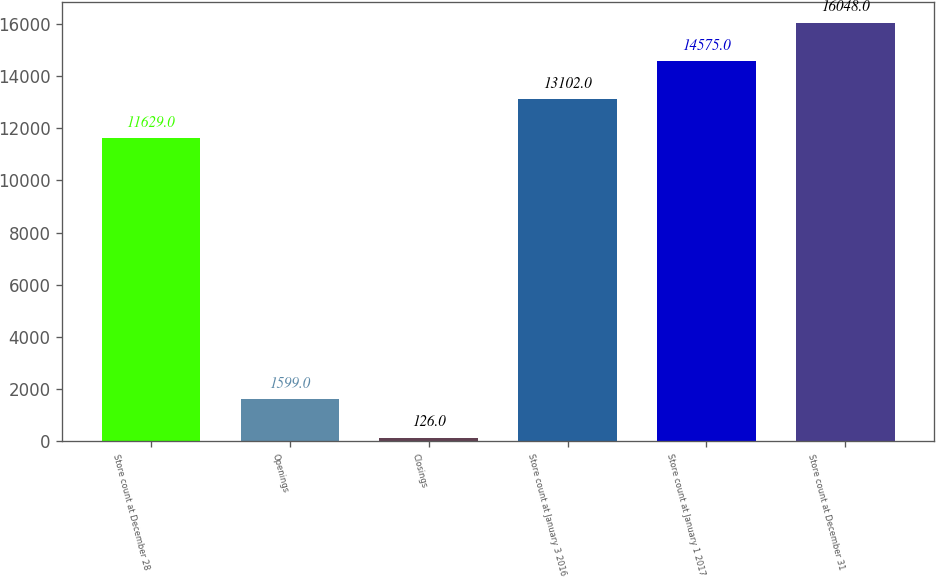Convert chart. <chart><loc_0><loc_0><loc_500><loc_500><bar_chart><fcel>Store count at December 28<fcel>Openings<fcel>Closings<fcel>Store count at January 3 2016<fcel>Store count at January 1 2017<fcel>Store count at December 31<nl><fcel>11629<fcel>1599<fcel>126<fcel>13102<fcel>14575<fcel>16048<nl></chart> 